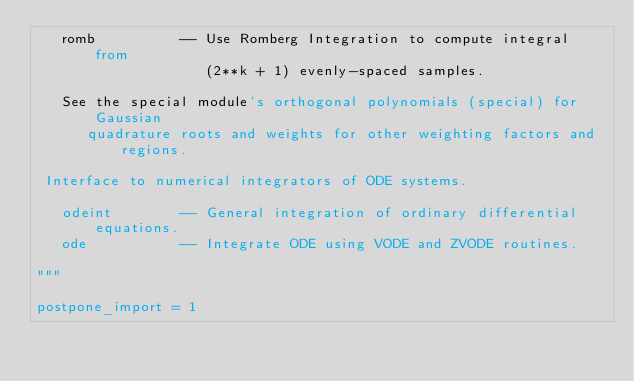Convert code to text. <code><loc_0><loc_0><loc_500><loc_500><_Python_>   romb          -- Use Romberg Integration to compute integral from
                    (2**k + 1) evenly-spaced samples.

   See the special module's orthogonal polynomials (special) for Gaussian
      quadrature roots and weights for other weighting factors and regions.

 Interface to numerical integrators of ODE systems.

   odeint        -- General integration of ordinary differential equations.
   ode           -- Integrate ODE using VODE and ZVODE routines.

"""

postpone_import = 1
</code> 